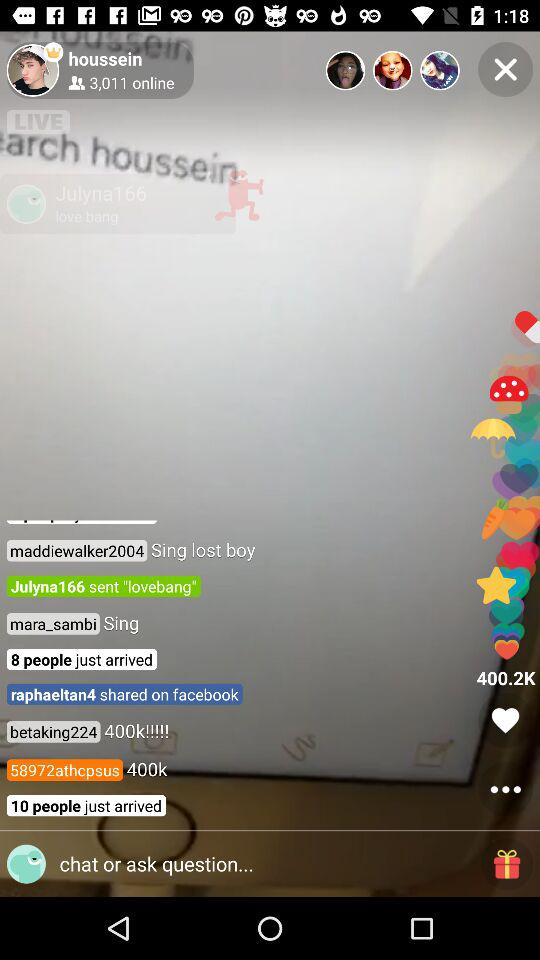How many people are online?
Answer the question using a single word or phrase. 3,011 